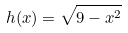Convert formula to latex. <formula><loc_0><loc_0><loc_500><loc_500>h ( x ) = \sqrt { 9 - x ^ { 2 } }</formula> 